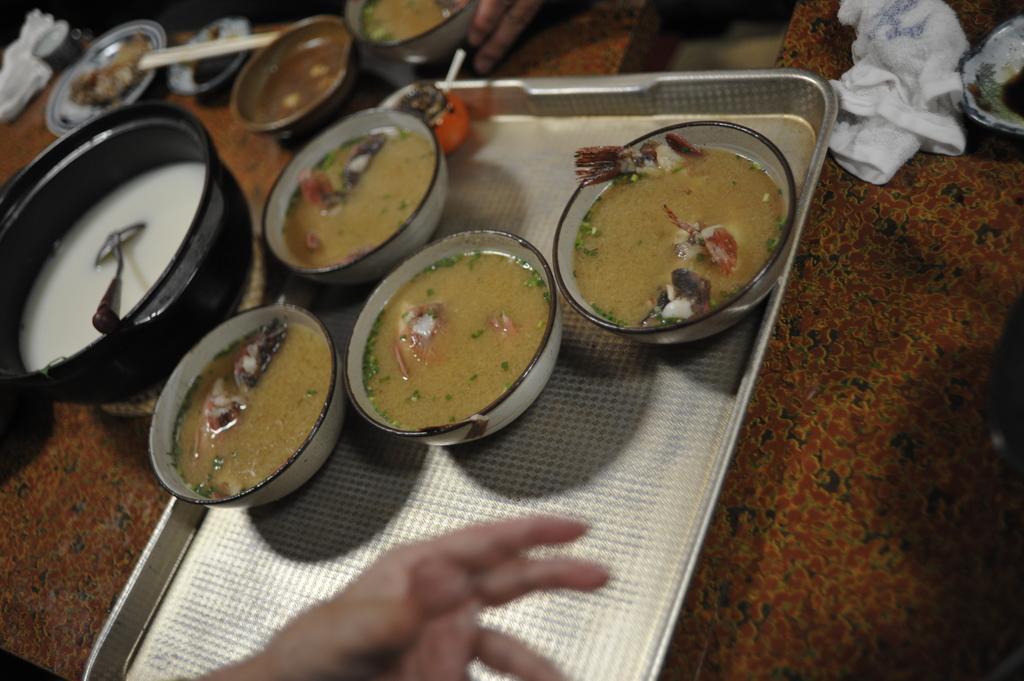Please provide a concise description of this image. In this picture we can see a person's hand and a platform, on this platform we can see a tray, bowls, food, spoon, cloth and some objects and in the background we can see a person's fingers. 